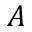Convert formula to latex. <formula><loc_0><loc_0><loc_500><loc_500>A</formula> 